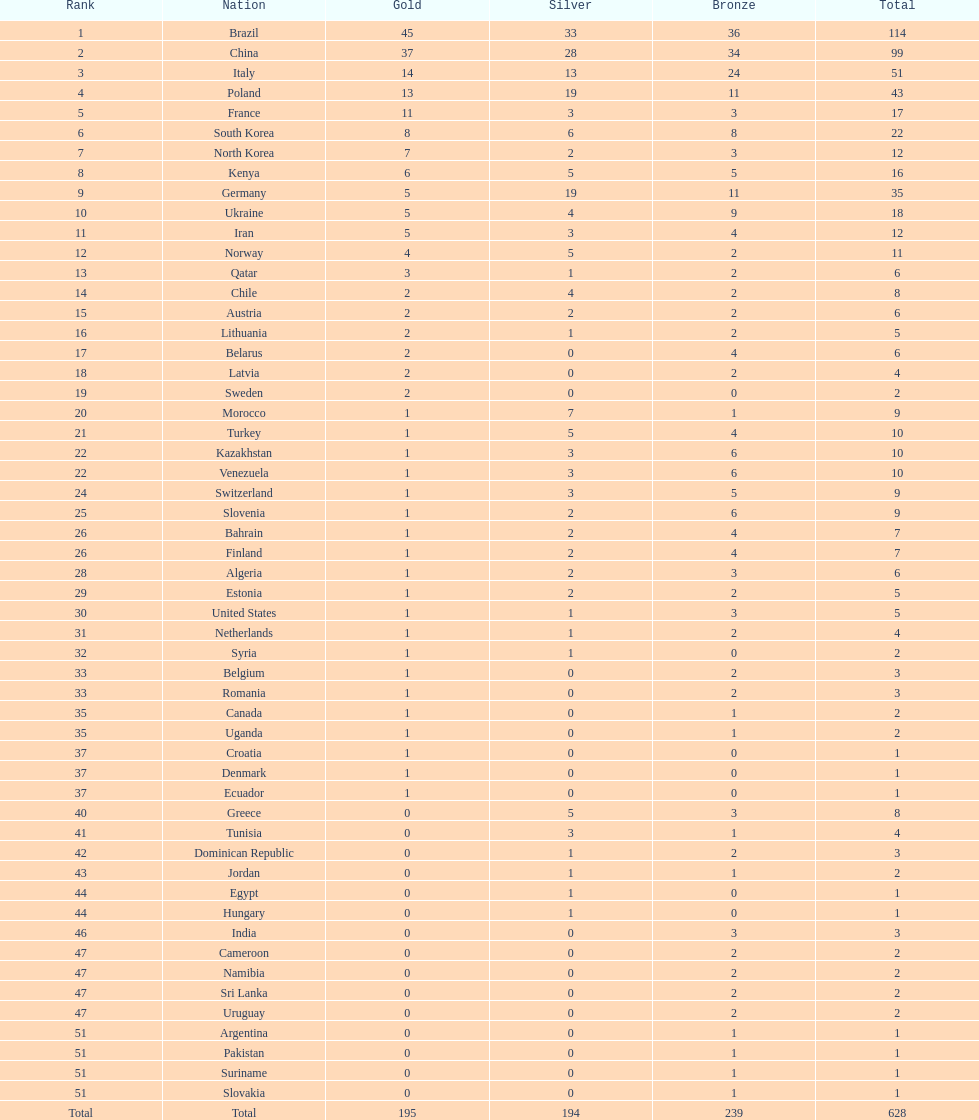What category of medal does belarus not possess? Silver. 